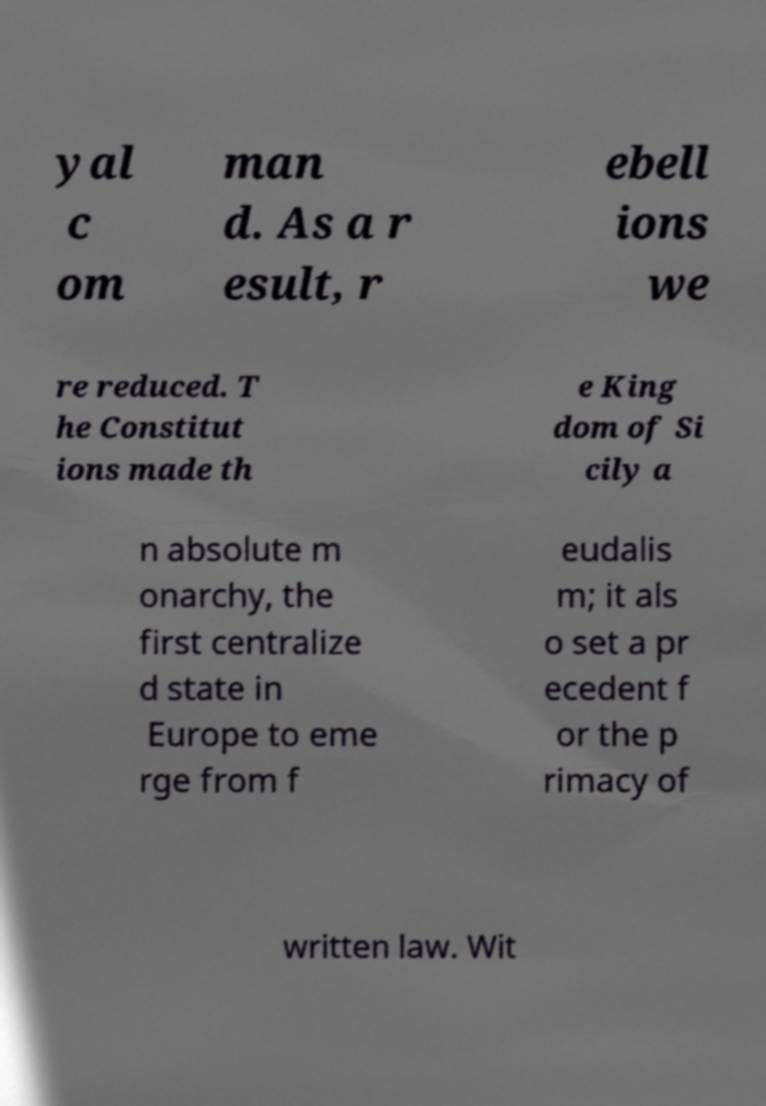Please read and relay the text visible in this image. What does it say? yal c om man d. As a r esult, r ebell ions we re reduced. T he Constitut ions made th e King dom of Si cily a n absolute m onarchy, the first centralize d state in Europe to eme rge from f eudalis m; it als o set a pr ecedent f or the p rimacy of written law. Wit 